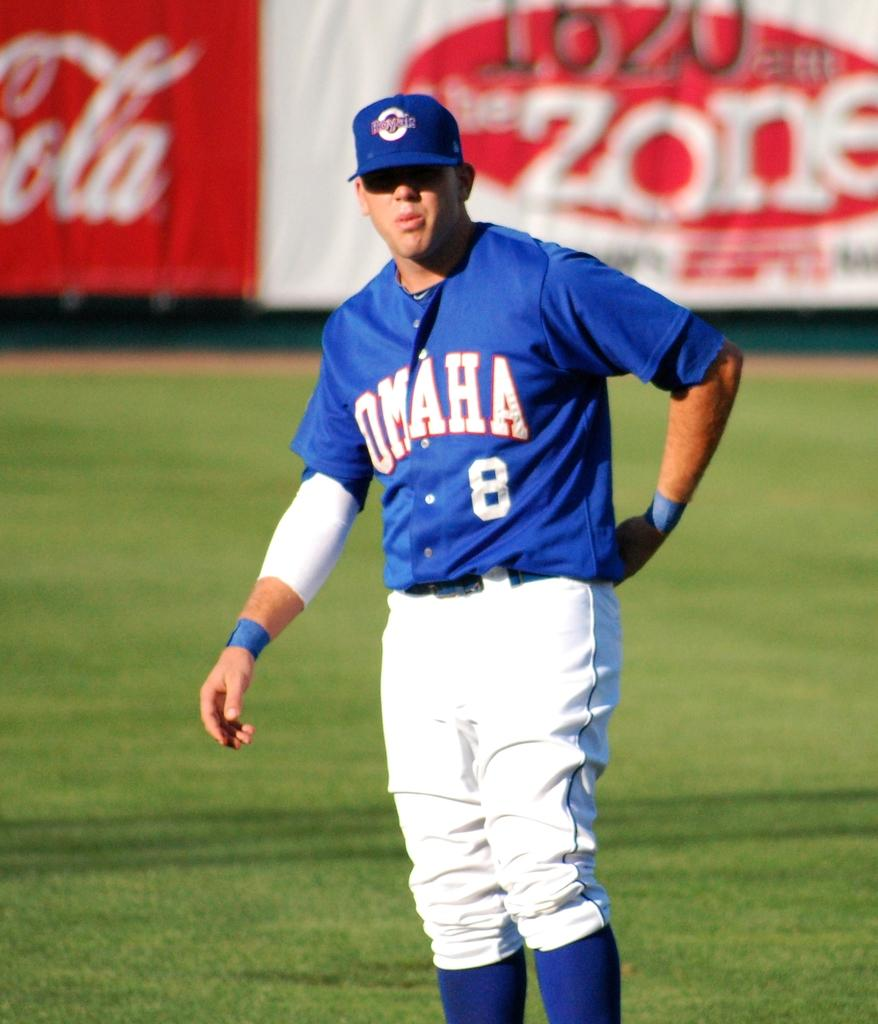<image>
Offer a succinct explanation of the picture presented. A Baseball player on the field playing for Omaha wearing the number 8 on his blue shirt wearing white pants. 